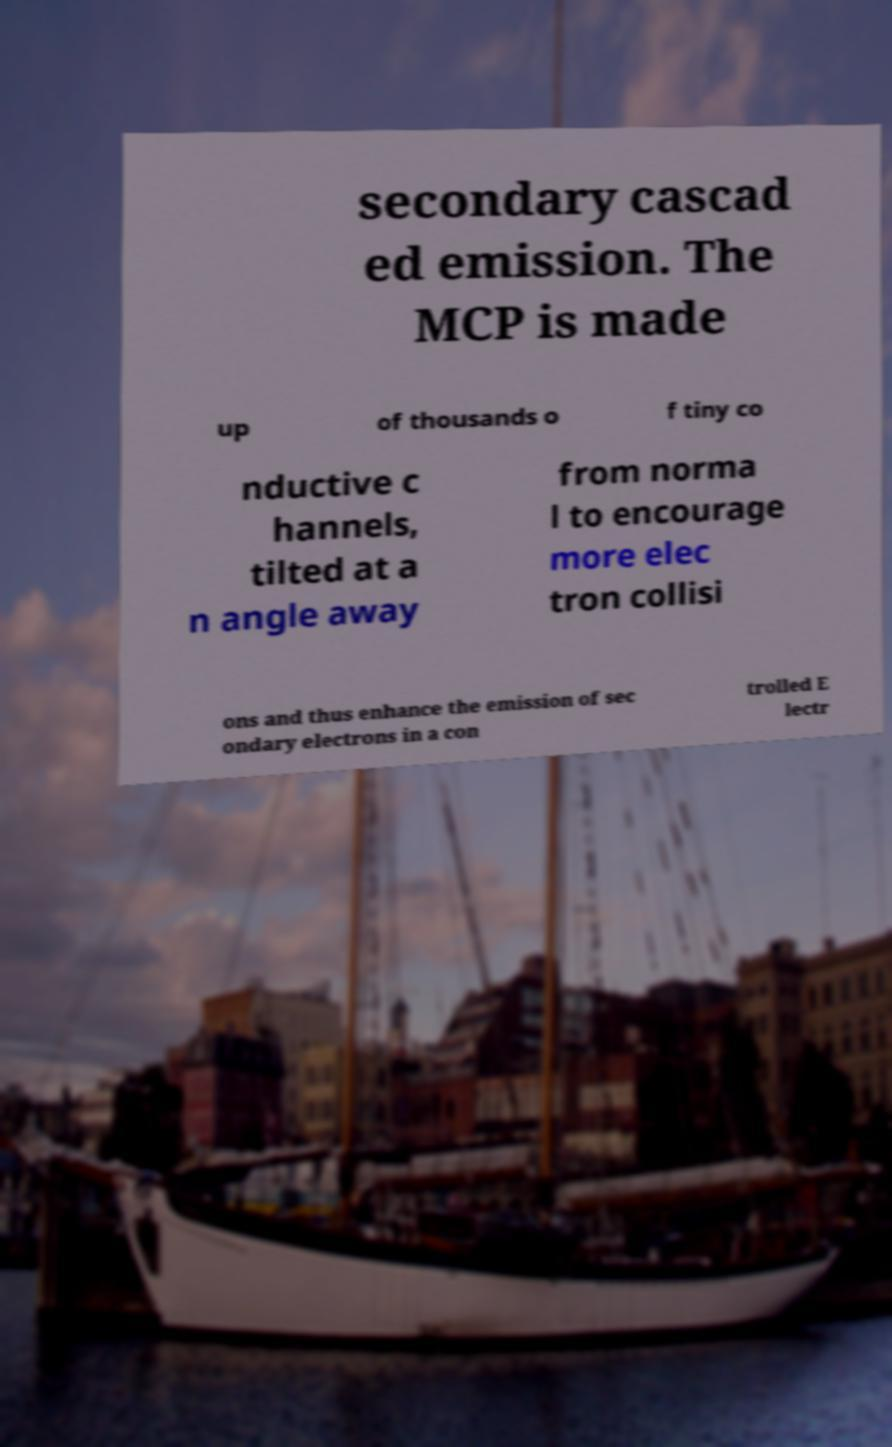Can you read and provide the text displayed in the image?This photo seems to have some interesting text. Can you extract and type it out for me? secondary cascad ed emission. The MCP is made up of thousands o f tiny co nductive c hannels, tilted at a n angle away from norma l to encourage more elec tron collisi ons and thus enhance the emission of sec ondary electrons in a con trolled E lectr 